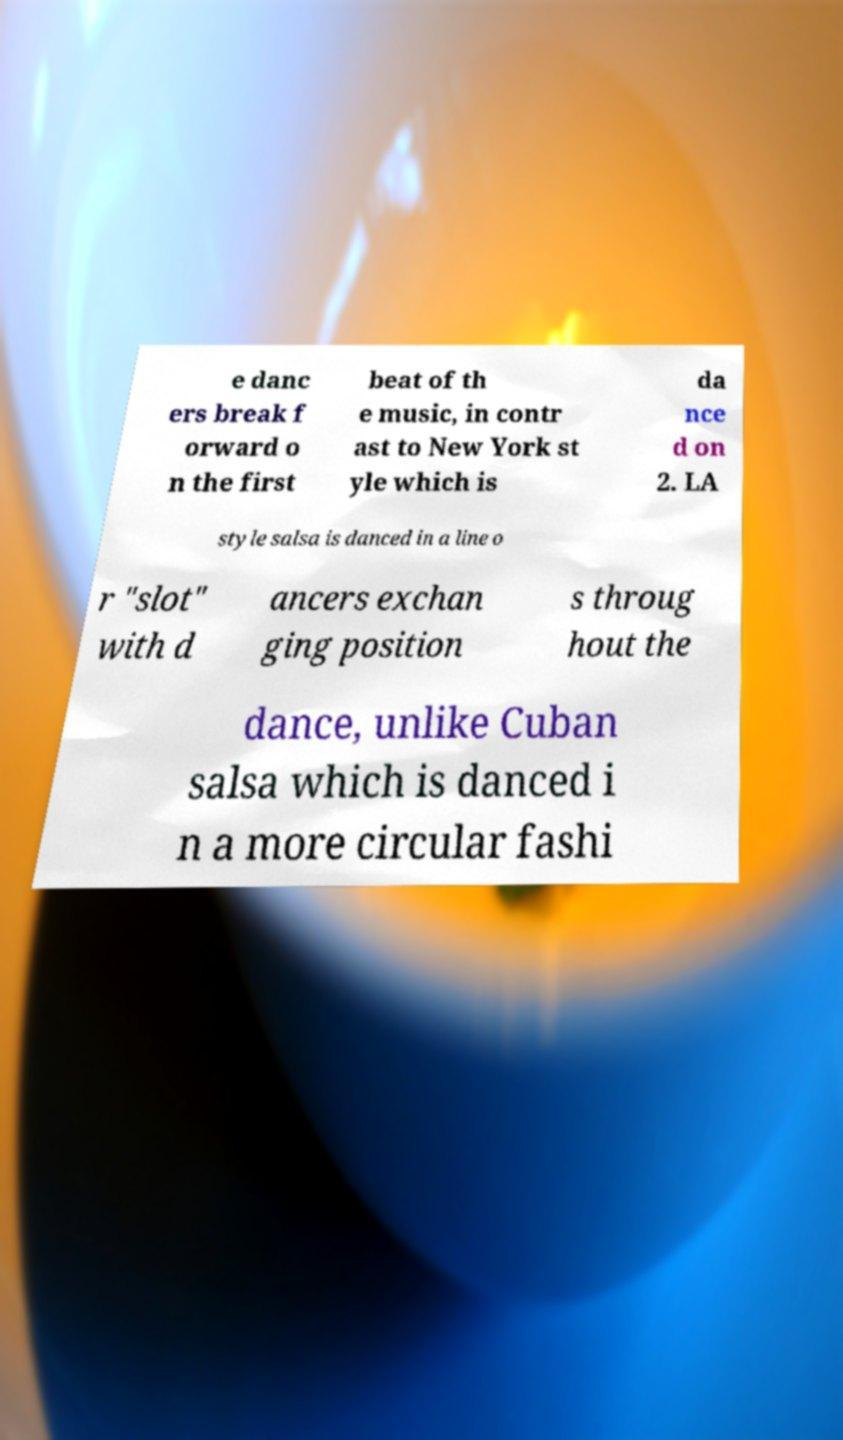Could you assist in decoding the text presented in this image and type it out clearly? e danc ers break f orward o n the first beat of th e music, in contr ast to New York st yle which is da nce d on 2. LA style salsa is danced in a line o r "slot" with d ancers exchan ging position s throug hout the dance, unlike Cuban salsa which is danced i n a more circular fashi 